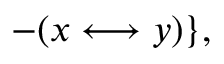Convert formula to latex. <formula><loc_0><loc_0><loc_500><loc_500>- ( x \longleftrightarrow y ) \} ,</formula> 